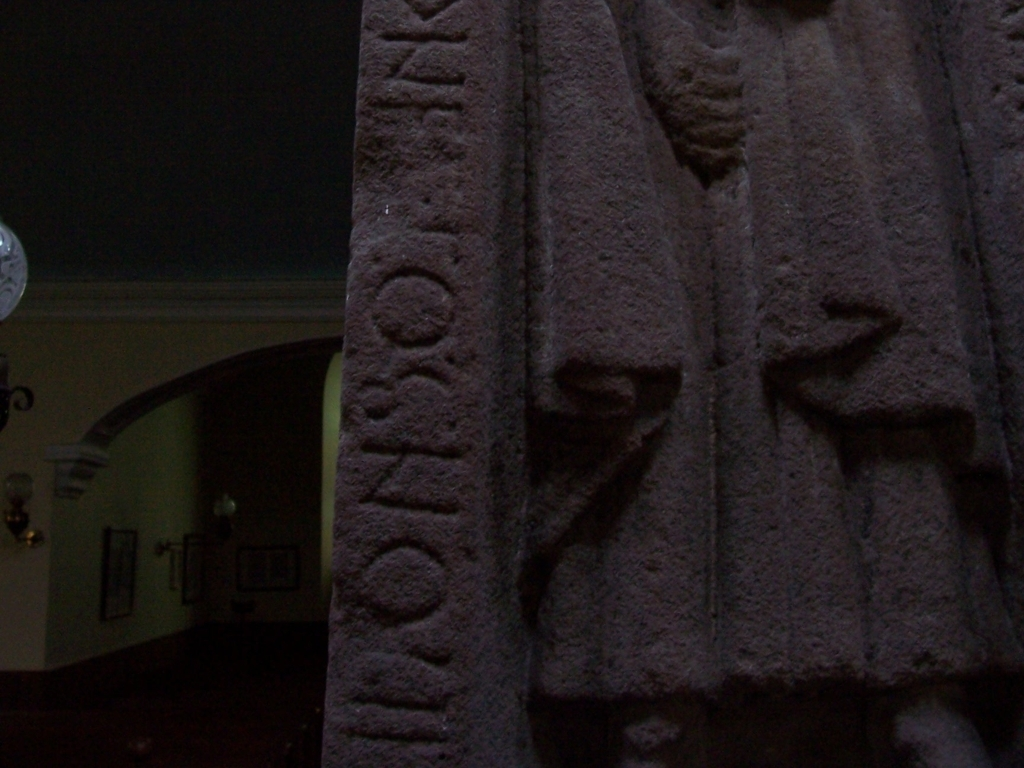What could be the historical significance of this artifact, based on what we see? Based on the image, if we assume this artifact is authentic, it could have great historical significance as a relic of past civilizations. The script carved into the stone may represent a language or form of writing from a particular era, possibly used for monumental inscriptions or official edicts. Its preservation and the context in which it was discovered (if known) could provide historians valuable insights into ancient customs, beliefs, or governmental systems. 